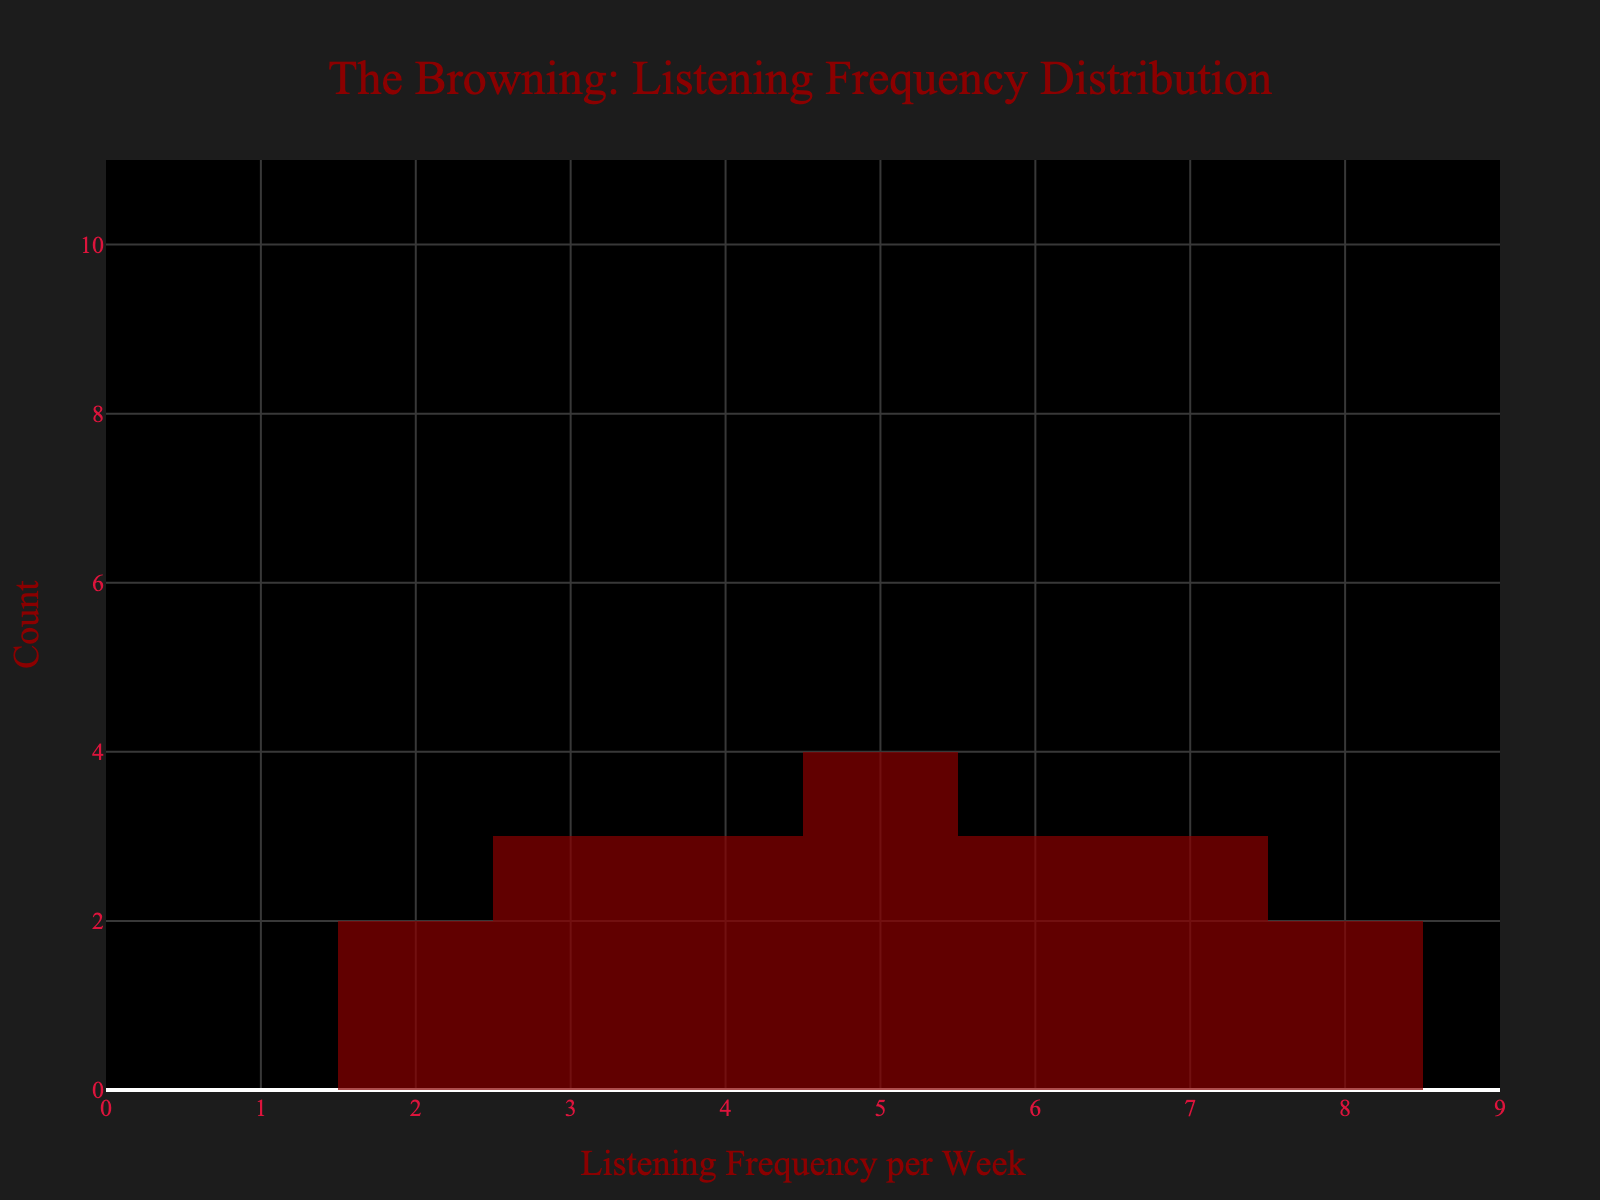What's the title of the plot? The title of the plot is typically found at the top and describes the content of the plot. In this case, the title is "The Browning: Listening Frequency Distribution".
Answer: The Browning: Listening Frequency Distribution What's the color of the histogram bars? The histogram bars are a specific shade of dark red which is visually distinct in the plot. This provides a clear visual cue for frequency distribution.
Answer: Dark red How many fans listen to The Browning's albums 7 times per week? In the histogram, count the number of bars that correspond to the frequency of 7 times per week. There are 3 bars at this frequency, indicating that 3 fans listen to the band's albums 7 times per week.
Answer: 3 Which listening frequency has the most fans? By examining the height of the bars in the histogram, the tallest bar corresponds to the frequency with the most fans. The frequency of 5 times per week has the tallest bar.
Answer: 5 times per week What's the range of the x-axis in this plot? The x-axis range can be determined by looking at the minimum and maximum values along the axis. Here it ranges from 0 to 9, as indicated in the plot.
Answer: 0 to 9 What's the mean listening frequency per week among the fans? To find the mean, sum up all listening frequencies provided in the data and divide by the number of fans. The frequencies are: 5, 7, 6, 3, 8, 4, 2, 6, 7, 5, 4, 3, 7, 5, 8, 6, 2, 5, 3, 4. The sum is 107 and there are 20 fans, so the mean is 107/20.
Answer: 5.35 What's the median listening frequency per week among the fans? To find the median, arrange the frequencies in ascending order and find the middle value. The ordered frequencies are: 2, 2, 3, 3, 3, 4, 4, 4, 5, 5, 5, 5, 6, 6, 6, 7, 7, 7, 8, 8. With 20 data points, the median is the average of the 10th and 11th values, which are both 5.
Answer: 5 How many fans listen to The Browning's albums more than 5 times per week? Count the number of data points where the frequency is greater than 5. There are: 7, 6, 8, 7, 7, 8, 6, 6, which totals 8 entries.
Answer: 8 What's the interquartile range (IQR) of the listening frequency? The IQR is calculated as the difference between the 75th percentile (Q3) and the 25th percentile (Q1). With the ordered frequencies: 2, 2, 3, 3, 3, 4, 4, 4, 5, 5, 5, 5, 6, 6, 6, 7, 7, 7, 8, 8, Q1 is 4 and Q3 is 6. The IQR is 6 - 4.
Answer: 2 What's the mode of the listening frequencies per week? The mode is the most frequently occurring value in the dataset. By examining the frequencies, the number 5 occurs more often than any other value.
Answer: 5 